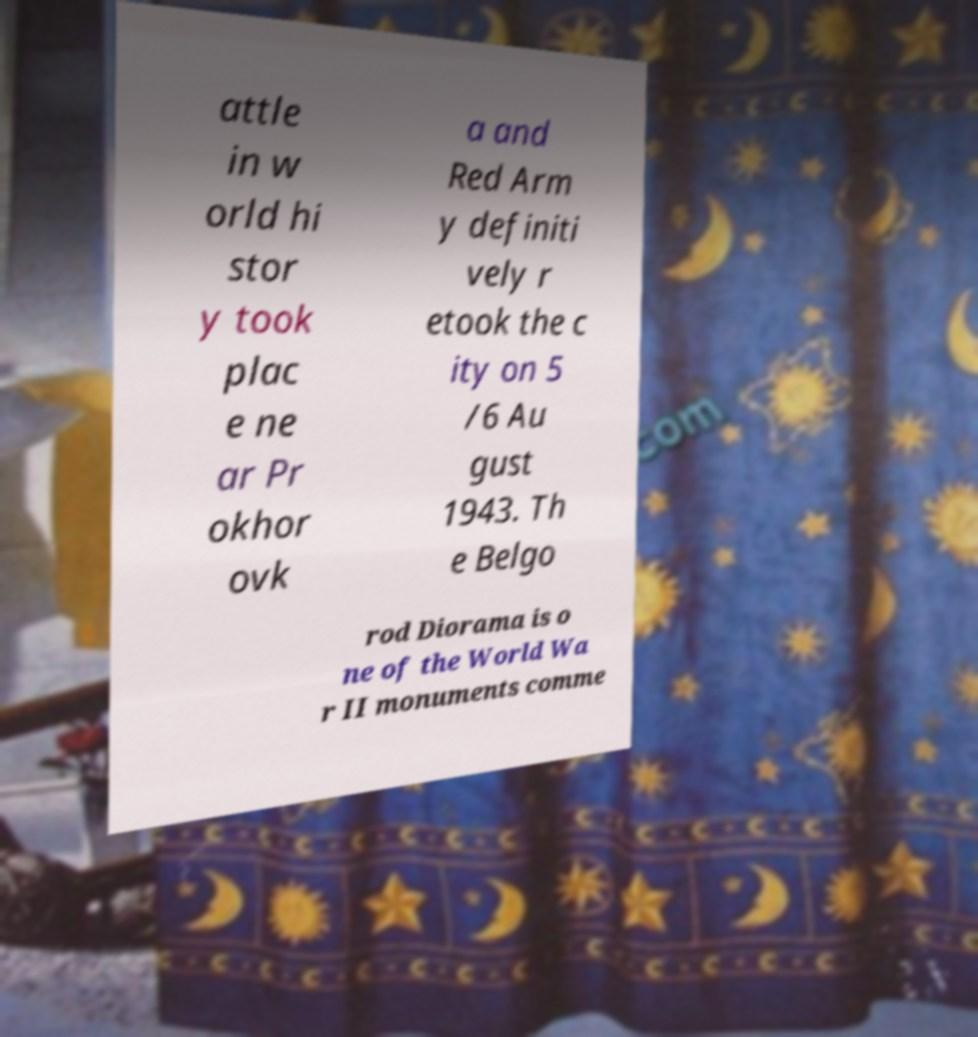Could you assist in decoding the text presented in this image and type it out clearly? attle in w orld hi stor y took plac e ne ar Pr okhor ovk a and Red Arm y definiti vely r etook the c ity on 5 /6 Au gust 1943. Th e Belgo rod Diorama is o ne of the World Wa r II monuments comme 